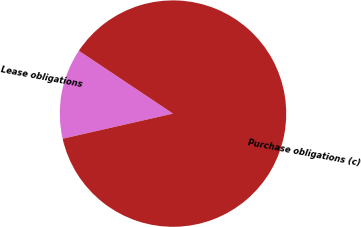<chart> <loc_0><loc_0><loc_500><loc_500><pie_chart><fcel>Lease obligations<fcel>Purchase obligations (c)<nl><fcel>12.93%<fcel>87.07%<nl></chart> 